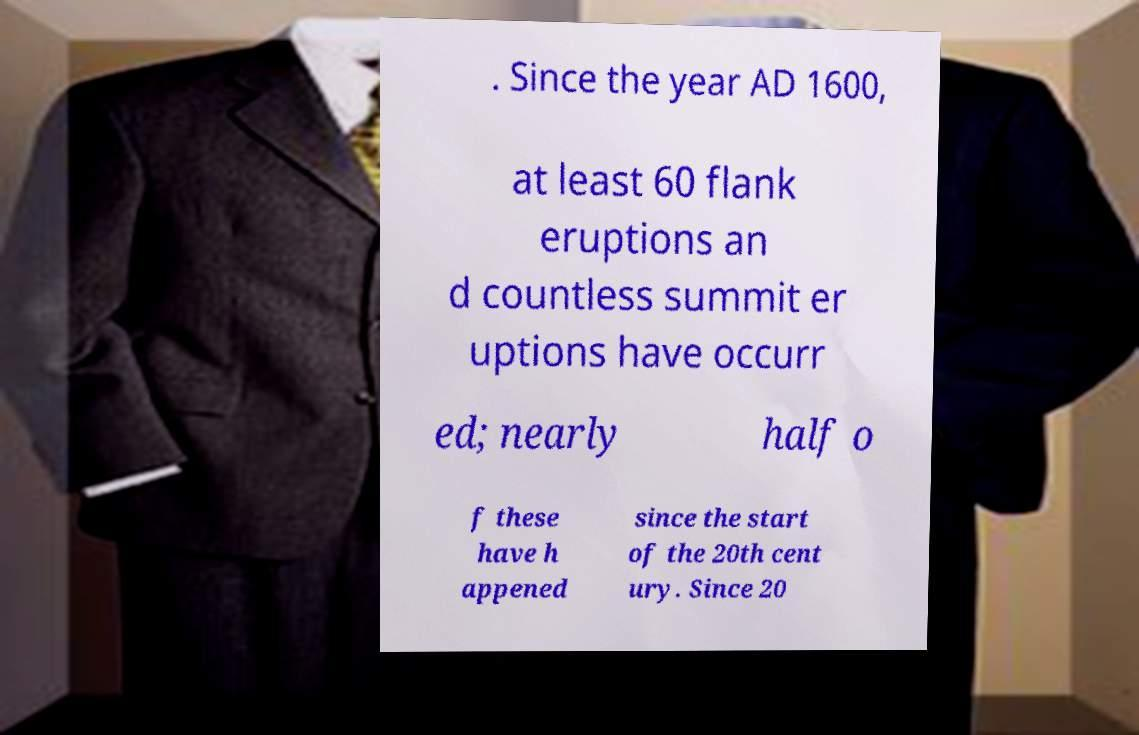Please identify and transcribe the text found in this image. . Since the year AD 1600, at least 60 flank eruptions an d countless summit er uptions have occurr ed; nearly half o f these have h appened since the start of the 20th cent ury. Since 20 